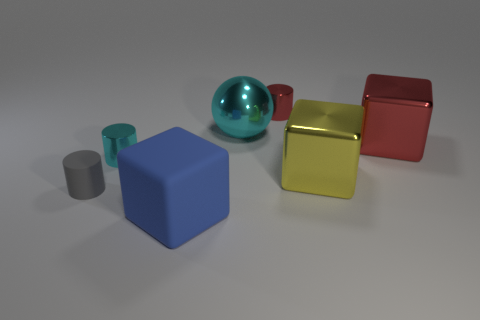Add 3 gray things. How many objects exist? 10 Subtract all spheres. How many objects are left? 6 Add 7 big shiny balls. How many big shiny balls are left? 8 Add 5 tiny cyan metallic cylinders. How many tiny cyan metallic cylinders exist? 6 Subtract 1 cyan cylinders. How many objects are left? 6 Subtract all brown cylinders. Subtract all cyan shiny objects. How many objects are left? 5 